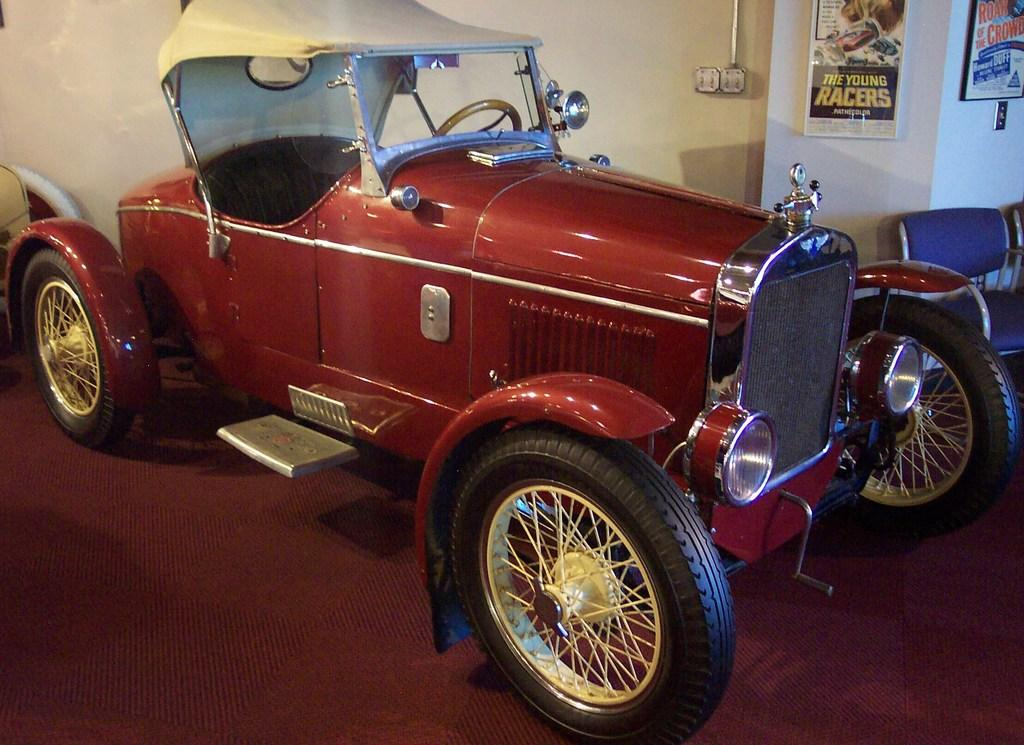What is the main subject in the center of the image? There is a car in the center of the image. What objects can be seen on the right side of the image? There are chairs on the right side of the image. What can be observed on the wall in the background of the image? There are posts placed on the wall in the background of the image. How many bears are sitting on the chairs in the image? There are no bears present in the image; it features a car, chairs, and posts on the wall. What message of hope can be seen on the car in the image? There is no message of hope visible on the car in the image. 